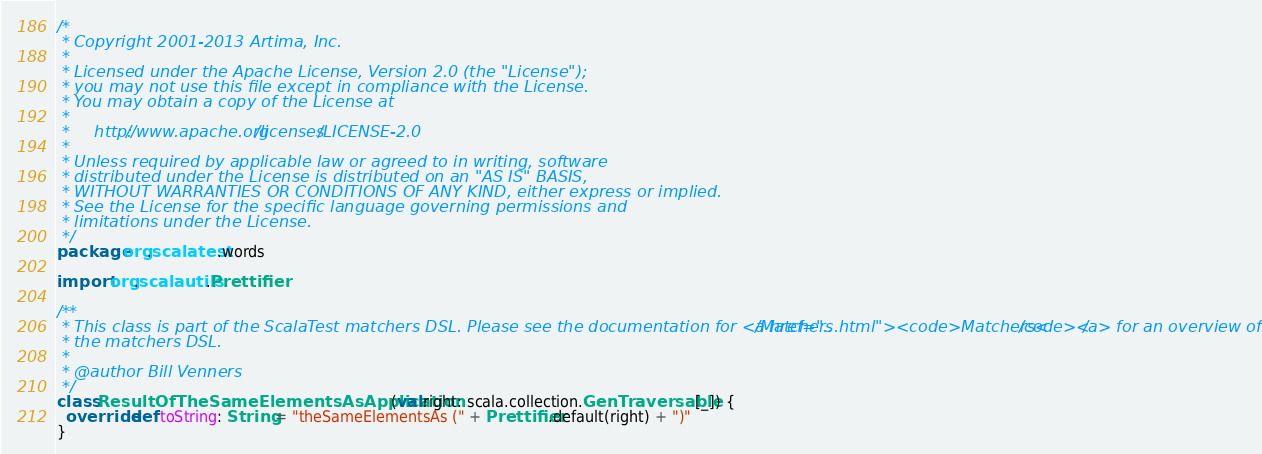<code> <loc_0><loc_0><loc_500><loc_500><_Scala_>/*
 * Copyright 2001-2013 Artima, Inc.
 *
 * Licensed under the Apache License, Version 2.0 (the "License");
 * you may not use this file except in compliance with the License.
 * You may obtain a copy of the License at
 *
 *     http://www.apache.org/licenses/LICENSE-2.0
 *
 * Unless required by applicable law or agreed to in writing, software
 * distributed under the License is distributed on an "AS IS" BASIS,
 * WITHOUT WARRANTIES OR CONDITIONS OF ANY KIND, either express or implied.
 * See the License for the specific language governing permissions and
 * limitations under the License.
 */
package org.scalatest.words

import org.scalautils.Prettifier

/**
 * This class is part of the ScalaTest matchers DSL. Please see the documentation for <a href="../Matchers.html"><code>Matchers</code></a> for an overview of
 * the matchers DSL.
 *
 * @author Bill Venners
 */
class ResultOfTheSameElementsAsApplication(val right: scala.collection.GenTraversable[_]) {
  override def toString: String = "theSameElementsAs (" + Prettifier.default(right) + ")" 
}</code> 